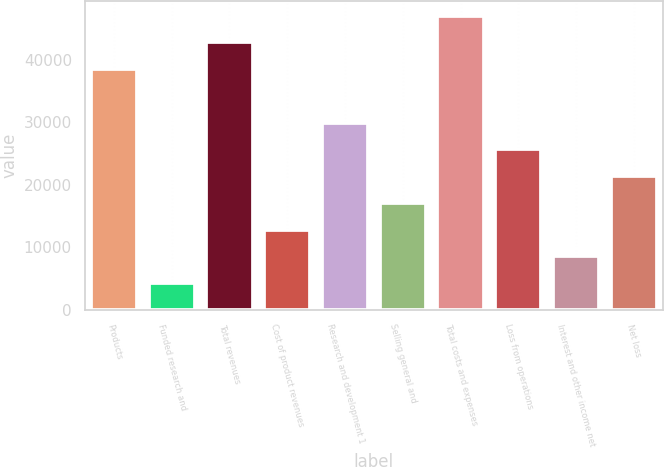<chart> <loc_0><loc_0><loc_500><loc_500><bar_chart><fcel>Products<fcel>Funded research and<fcel>Total revenues<fcel>Cost of product revenues<fcel>Research and development 1<fcel>Selling general and<fcel>Total costs and expenses<fcel>Loss from operations<fcel>Interest and other income net<fcel>Net loss<nl><fcel>38521<fcel>4280.88<fcel>42801<fcel>12840.9<fcel>29960.9<fcel>17120.9<fcel>47081<fcel>25680.9<fcel>8560.89<fcel>21400.9<nl></chart> 